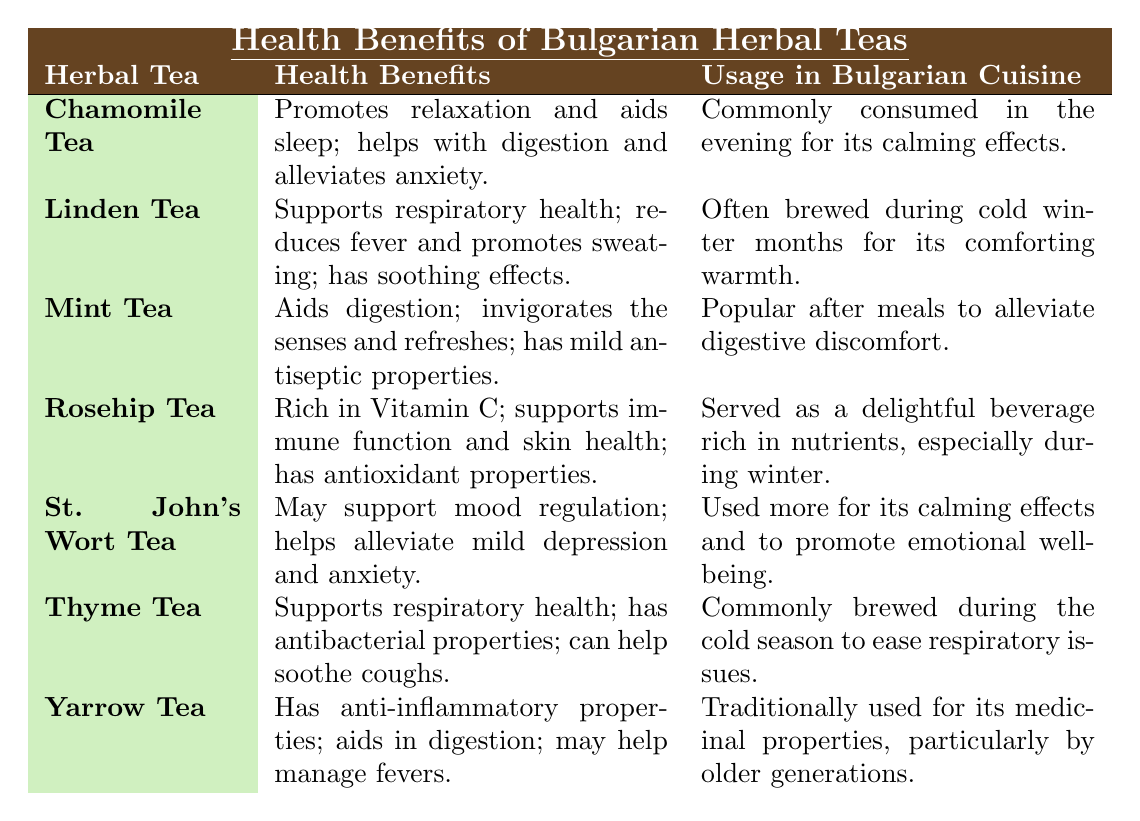What health benefit is associated with Chamomile Tea? Chamomile Tea is noted for promoting relaxation, aiding sleep, helping with digestion, and alleviating anxiety as stated in the table.
Answer: Promotes relaxation and aids sleep Which herbal tea is rich in Vitamin C? The table mentions that Rosehip Tea is rich in Vitamin C and supports immune function and skin health.
Answer: Rosehip Tea Is Mint Tea used before or after meals? According to the table, Mint Tea is popular after meals to alleviate digestive discomfort.
Answer: After meals Which herbal tea supports mood regulation? The table specifies that St. John's Wort Tea may support mood regulation and helps alleviate mild depression and anxiety.
Answer: St. John's Wort Tea What are the health benefits of Yarrow Tea? The table lists the health benefits of Yarrow Tea as having anti-inflammatory properties, aiding digestion, and possibly helping manage fevers.
Answer: Anti-inflammatory properties; aids in digestion; may help manage fevers Which herbal tea is commonly brewed during cold winter months? The table states that both Linden Tea and Thyme Tea are commonly brewed during the cold winter months.
Answer: Linden Tea and Thyme Tea Which herbal tea has antibacterial properties? From the table, Thyme Tea is noted to have antibacterial properties among its health benefits.
Answer: Thyme Tea How many herbal teas are specifically mentioned in the table? By counting, the table lists a total of 7 herbal teas: Chamomile, Linden, Mint, Rosehip, St. John's Wort, Thyme, and Yarrow.
Answer: 7 Which teas support respiratory health? The table indicates that Linden Tea and Thyme Tea both support respiratory health.
Answer: Linden Tea and Thyme Tea Is it true that all herbal teas listed provide digestive benefits? Not all herbal teas provide digestive benefits; only Chamomile Tea, Mint Tea, and Yarrow Tea have specific mentions of aiding digestion in the table.
Answer: No 